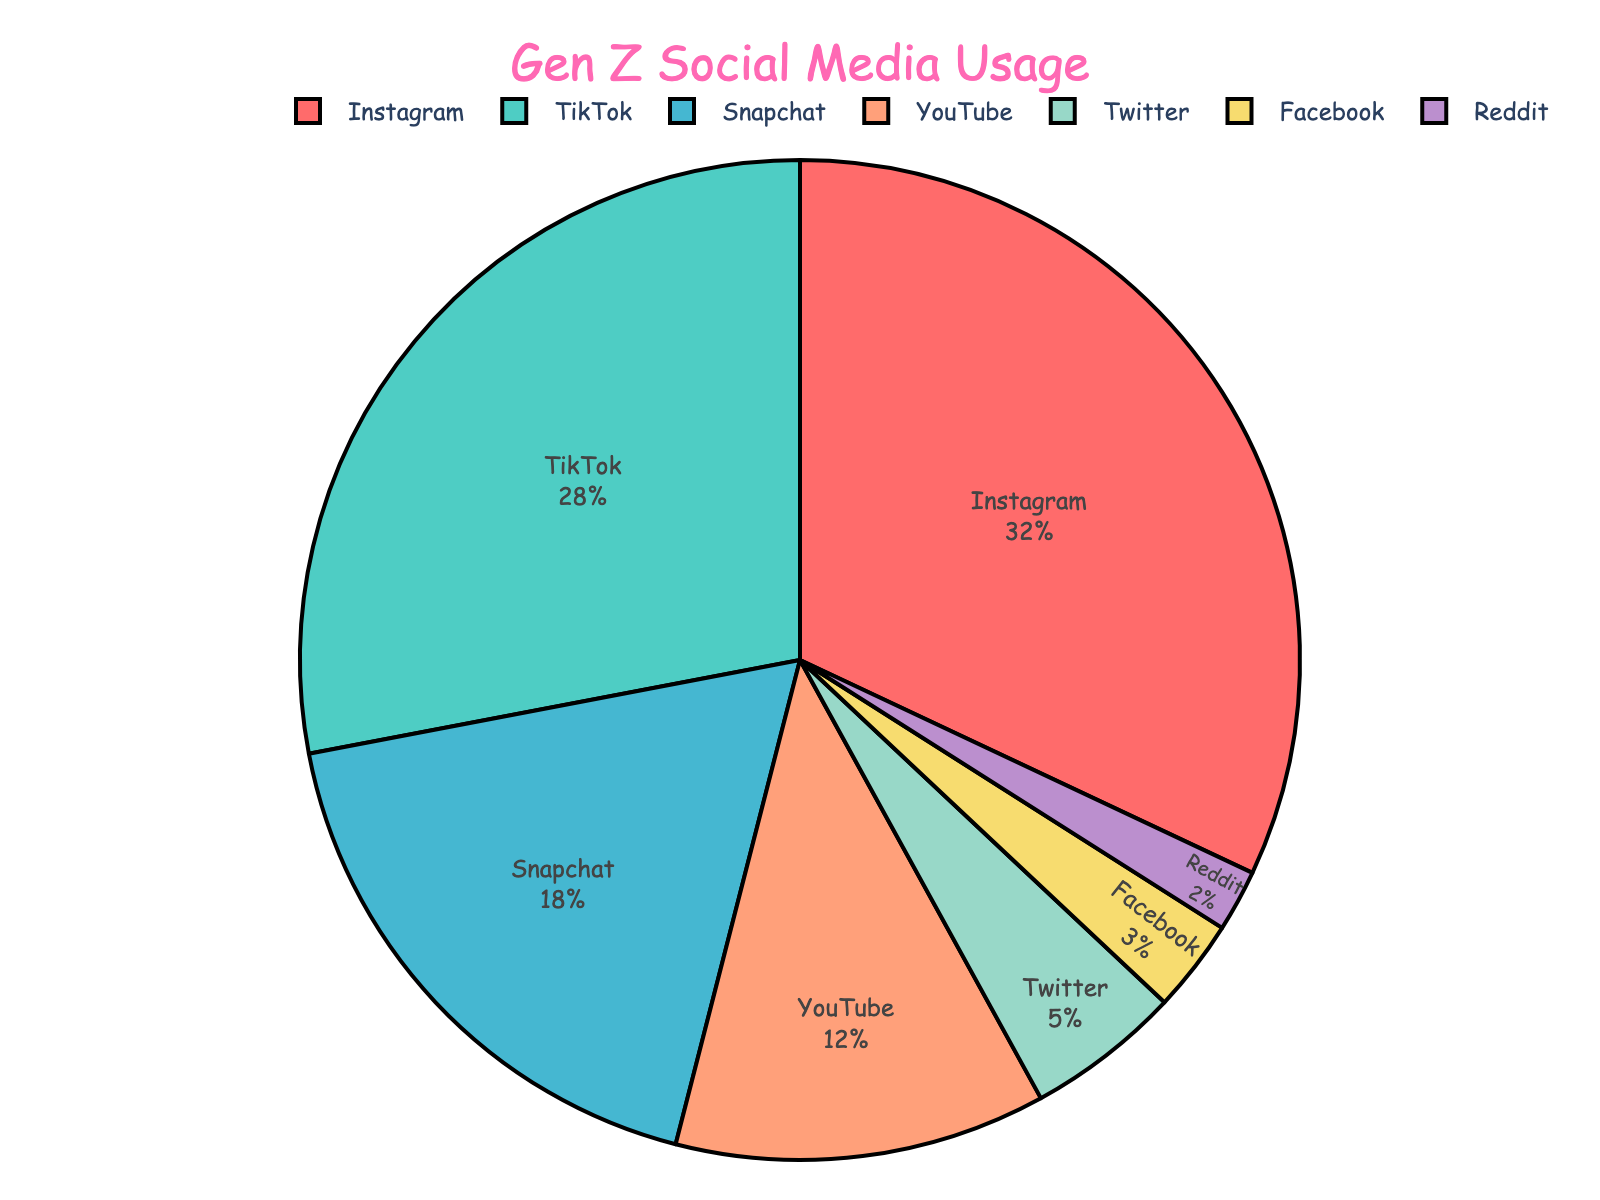What's the most popular social media platform among Gen Z? The platform with the highest percentage is the most popular. From the chart, Instagram has the highest percentage of 32%.
Answer: Instagram What's the total percentage of usage for TikTok and Snapchat combined? Add the percentages of TikTok and Snapchat: TikTok (28%) + Snapchat (18%) = 46%.
Answer: 46% Is YouTube more popular than Twitter among Gen Z? Compare the percentages of YouTube and Twitter. YouTube has 12% while Twitter has 5%. Since 12% is greater than 5%, YouTube is more popular.
Answer: Yes Which platform has the least usage among Gen Z? Look for the platform with the smallest percentage. Reddit has the smallest percentage at 2%.
Answer: Reddit How much more popular is Instagram compared to Facebook? Subtract the percentage of Facebook from Instagram: Instagram (32%) - Facebook (3%) = 29%.
Answer: 29% Which platforms have a combined percentage of 15%? Identify platforms whose combined percentages equal 15%. Twitter (5%) + Facebook (3%) + Reddit (2%) = 10% (not enough). Next, see if another combination works. YouTube (12%) + Twitter (5%) = 17% (too much). No straightforward pairs clearly add to precisely 15%.
Answer: None What percentage of social media usage does YouTube and Facebook have together? Add the percentages of YouTube and Facebook: YouTube (12%) + Facebook (3%) = 15%.
Answer: 15% Arrange the platforms in descending order of their usage among Gen Z. List the platforms from the highest to the lowest percentage: Instagram (32%), TikTok (28%), Snapchat (18%), YouTube (12%), Twitter (5%), Facebook (3%), Reddit (2%).
Answer: Instagram, TikTok, Snapchat, YouTube, Twitter, Facebook, Reddit Which color represents Snapchat in the chart? Identify the color associated with Snapchat. The chart shows Snapchat in a light blue color.
Answer: Light blue If you combine Instagram, TikTok, and Snapchat, what percentage of Gen Z does that represent? Add the percentages of Instagram, TikTok, and Snapchat: Instagram (32%) + TikTok (28%) + Snapchat (18%) = 78%.
Answer: 78% 